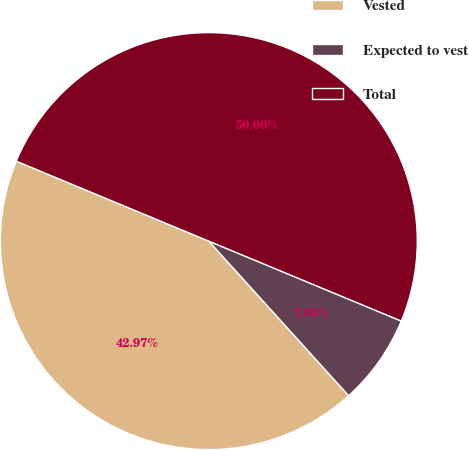Convert chart. <chart><loc_0><loc_0><loc_500><loc_500><pie_chart><fcel>Vested<fcel>Expected to vest<fcel>Total<nl><fcel>42.97%<fcel>7.03%<fcel>50.0%<nl></chart> 